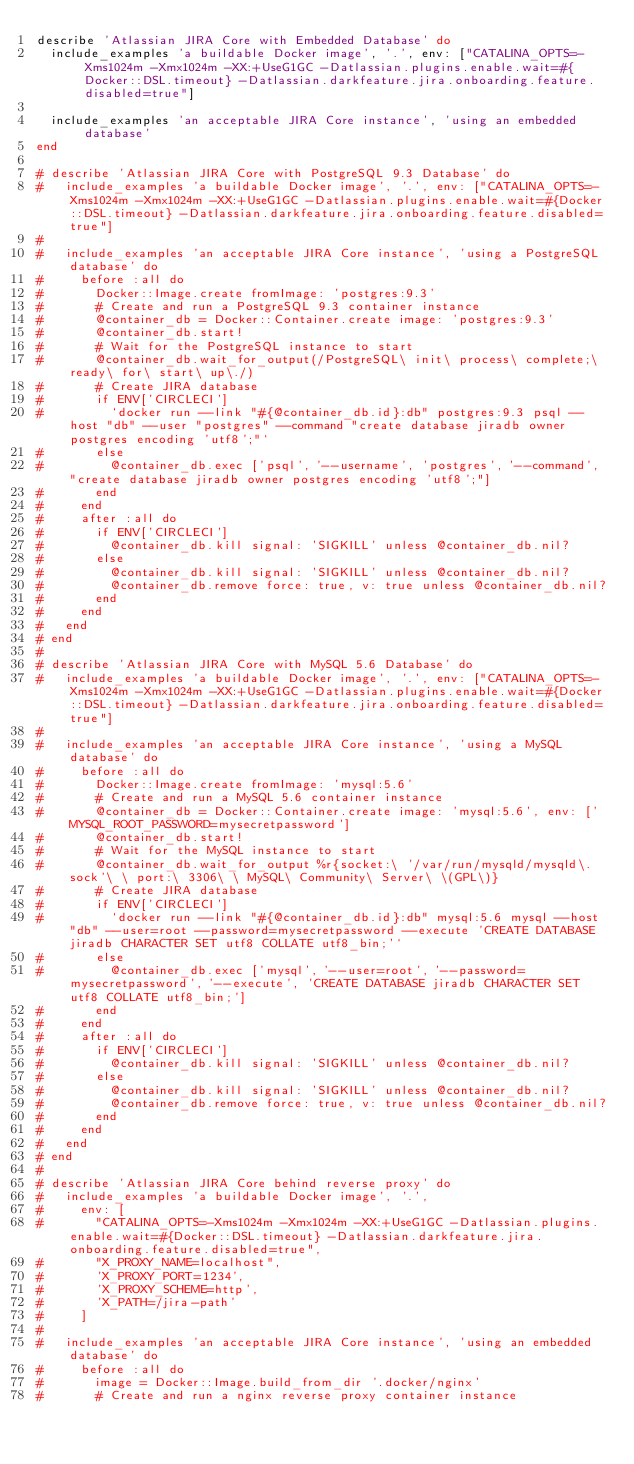Convert code to text. <code><loc_0><loc_0><loc_500><loc_500><_Ruby_>describe 'Atlassian JIRA Core with Embedded Database' do
  include_examples 'a buildable Docker image', '.', env: ["CATALINA_OPTS=-Xms1024m -Xmx1024m -XX:+UseG1GC -Datlassian.plugins.enable.wait=#{Docker::DSL.timeout} -Datlassian.darkfeature.jira.onboarding.feature.disabled=true"]

  include_examples 'an acceptable JIRA Core instance', 'using an embedded database'
end

# describe 'Atlassian JIRA Core with PostgreSQL 9.3 Database' do
#   include_examples 'a buildable Docker image', '.', env: ["CATALINA_OPTS=-Xms1024m -Xmx1024m -XX:+UseG1GC -Datlassian.plugins.enable.wait=#{Docker::DSL.timeout} -Datlassian.darkfeature.jira.onboarding.feature.disabled=true"]
# 
#   include_examples 'an acceptable JIRA Core instance', 'using a PostgreSQL database' do
#     before :all do
#       Docker::Image.create fromImage: 'postgres:9.3'
#       # Create and run a PostgreSQL 9.3 container instance
#       @container_db = Docker::Container.create image: 'postgres:9.3'
#       @container_db.start!
#       # Wait for the PostgreSQL instance to start
#       @container_db.wait_for_output(/PostgreSQL\ init\ process\ complete;\ ready\ for\ start\ up\./)
#       # Create JIRA database
#       if ENV['CIRCLECI']
#         `docker run --link "#{@container_db.id}:db" postgres:9.3 psql --host "db" --user "postgres" --command "create database jiradb owner postgres encoding 'utf8';"`
#       else
#         @container_db.exec ['psql', '--username', 'postgres', '--command', "create database jiradb owner postgres encoding 'utf8';"]
#       end
#     end
#     after :all do
#       if ENV['CIRCLECI']
#         @container_db.kill signal: 'SIGKILL' unless @container_db.nil?
#       else
#         @container_db.kill signal: 'SIGKILL' unless @container_db.nil?
#         @container_db.remove force: true, v: true unless @container_db.nil?
#       end
#     end
#   end
# end
# 
# describe 'Atlassian JIRA Core with MySQL 5.6 Database' do
#   include_examples 'a buildable Docker image', '.', env: ["CATALINA_OPTS=-Xms1024m -Xmx1024m -XX:+UseG1GC -Datlassian.plugins.enable.wait=#{Docker::DSL.timeout} -Datlassian.darkfeature.jira.onboarding.feature.disabled=true"]
# 
#   include_examples 'an acceptable JIRA Core instance', 'using a MySQL database' do
#     before :all do
#       Docker::Image.create fromImage: 'mysql:5.6'
#       # Create and run a MySQL 5.6 container instance
#       @container_db = Docker::Container.create image: 'mysql:5.6', env: ['MYSQL_ROOT_PASSWORD=mysecretpassword']
#       @container_db.start!
#       # Wait for the MySQL instance to start
#       @container_db.wait_for_output %r{socket:\ '/var/run/mysqld/mysqld\.sock'\ \ port:\ 3306\ \ MySQL\ Community\ Server\ \(GPL\)}
#       # Create JIRA database
#       if ENV['CIRCLECI']
#         `docker run --link "#{@container_db.id}:db" mysql:5.6 mysql --host "db" --user=root --password=mysecretpassword --execute 'CREATE DATABASE jiradb CHARACTER SET utf8 COLLATE utf8_bin;'`
#       else
#         @container_db.exec ['mysql', '--user=root', '--password=mysecretpassword', '--execute', 'CREATE DATABASE jiradb CHARACTER SET utf8 COLLATE utf8_bin;']
#       end
#     end
#     after :all do
#       if ENV['CIRCLECI']
#         @container_db.kill signal: 'SIGKILL' unless @container_db.nil?
#       else
#         @container_db.kill signal: 'SIGKILL' unless @container_db.nil?
#         @container_db.remove force: true, v: true unless @container_db.nil?
#       end
#     end
#   end
# end
# 
# describe 'Atlassian JIRA Core behind reverse proxy' do
#   include_examples 'a buildable Docker image', '.',
#     env: [
#       "CATALINA_OPTS=-Xms1024m -Xmx1024m -XX:+UseG1GC -Datlassian.plugins.enable.wait=#{Docker::DSL.timeout} -Datlassian.darkfeature.jira.onboarding.feature.disabled=true",
#       "X_PROXY_NAME=localhost",
#       'X_PROXY_PORT=1234',
#       'X_PROXY_SCHEME=http',
#       'X_PATH=/jira-path'
#     ]
# 
#   include_examples 'an acceptable JIRA Core instance', 'using an embedded database' do
#     before :all do
#       image = Docker::Image.build_from_dir '.docker/nginx'
#       # Create and run a nginx reverse proxy container instance</code> 